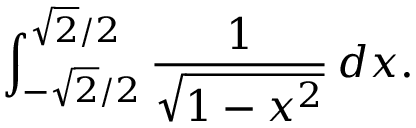<formula> <loc_0><loc_0><loc_500><loc_500>\int _ { - { \sqrt { 2 } } / 2 } ^ { { \sqrt { 2 } } / 2 } { \frac { 1 } { \sqrt { 1 - x ^ { 2 } } } } \, d x .</formula> 